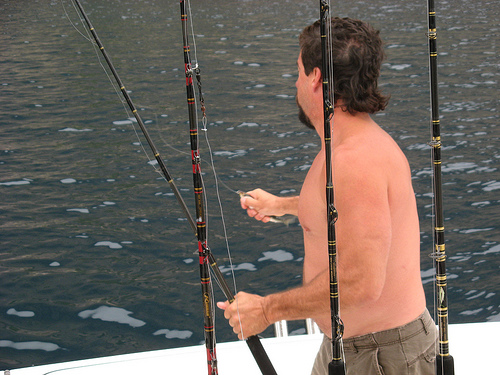<image>
Is there a man in the fishing pole? No. The man is not contained within the fishing pole. These objects have a different spatial relationship. Where is the pole in relation to the other pole? Is it next to the other pole? No. The pole is not positioned next to the other pole. They are located in different areas of the scene. 